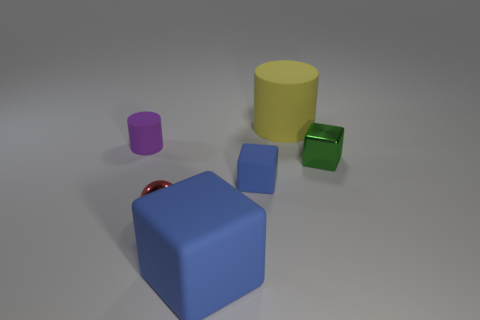Subtract all red balls. How many blue blocks are left? 2 Subtract all small blocks. How many blocks are left? 1 Subtract 1 cubes. How many cubes are left? 2 Add 4 green cubes. How many objects exist? 10 Subtract all cylinders. How many objects are left? 4 Subtract all yellow rubber objects. Subtract all large matte cylinders. How many objects are left? 4 Add 3 big yellow rubber objects. How many big yellow rubber objects are left? 4 Add 1 large cyan cylinders. How many large cyan cylinders exist? 1 Subtract 0 yellow cubes. How many objects are left? 6 